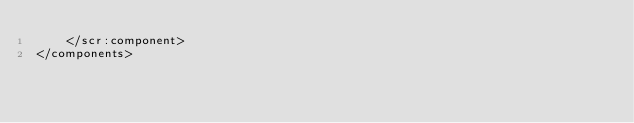Convert code to text. <code><loc_0><loc_0><loc_500><loc_500><_XML_>    </scr:component>
</components>
</code> 